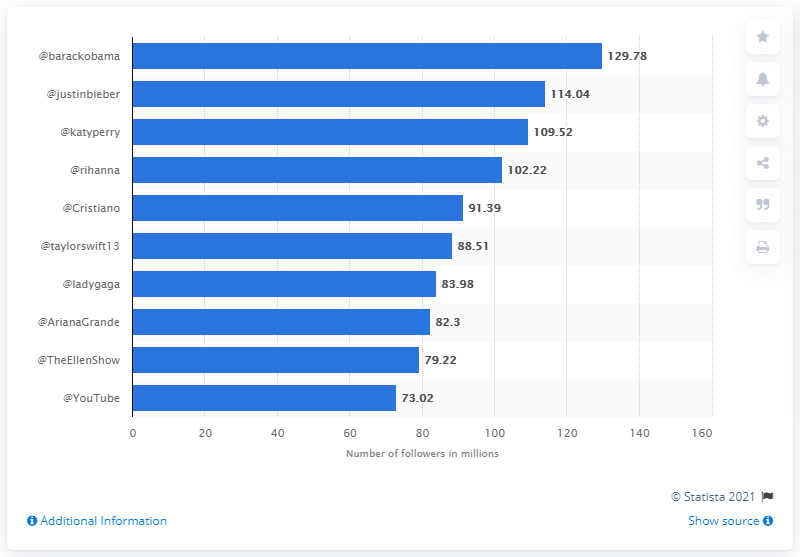Give some essential details in this illustration. As of a certain point in time, Justin Bieber had 114.04 followers on his social media account. As of March 2021, Barack Obama had 129,789 people following his Twitter account. The bars in the graph are arranged in a way that allows the viewer to determine whether they are sorted from top to bottom by simply looking at the graph. The answer to the question of whether the bars are sorted from top to bottom in this graph is yes. The difference in the number of followers between the most and least followed Twitter accounts is 56.76. 